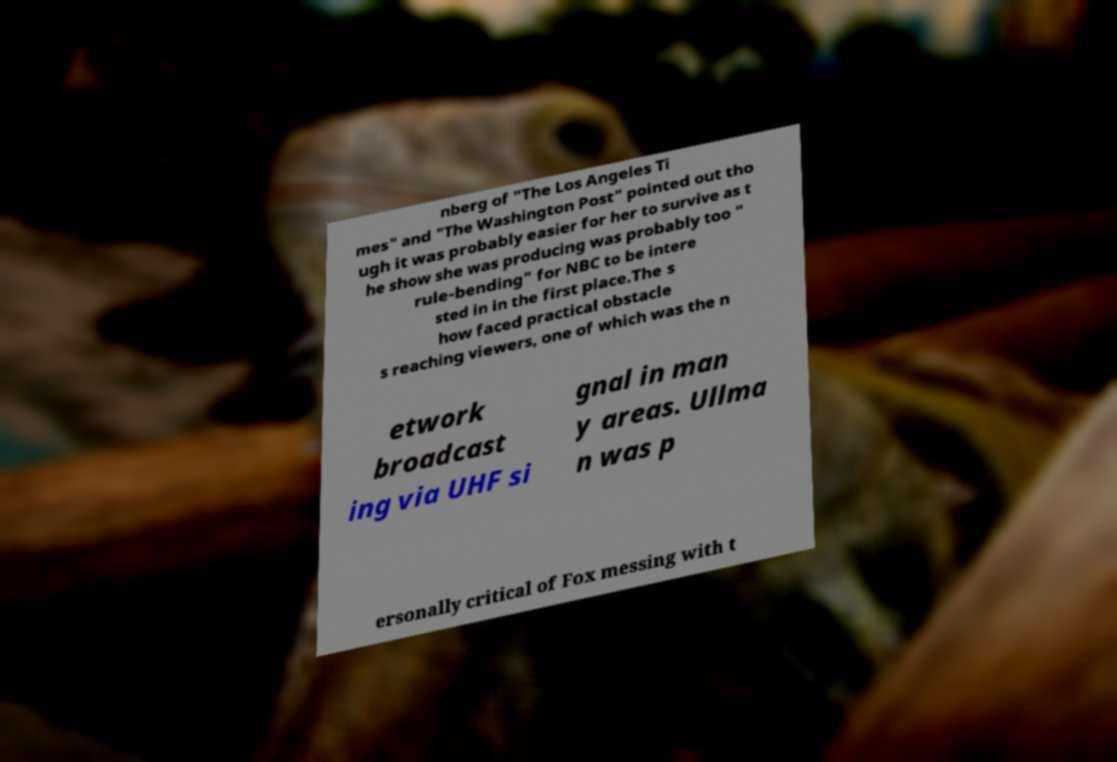For documentation purposes, I need the text within this image transcribed. Could you provide that? nberg of "The Los Angeles Ti mes" and "The Washington Post" pointed out tho ugh it was probably easier for her to survive as t he show she was producing was probably too " rule-bending" for NBC to be intere sted in in the first place.The s how faced practical obstacle s reaching viewers, one of which was the n etwork broadcast ing via UHF si gnal in man y areas. Ullma n was p ersonally critical of Fox messing with t 